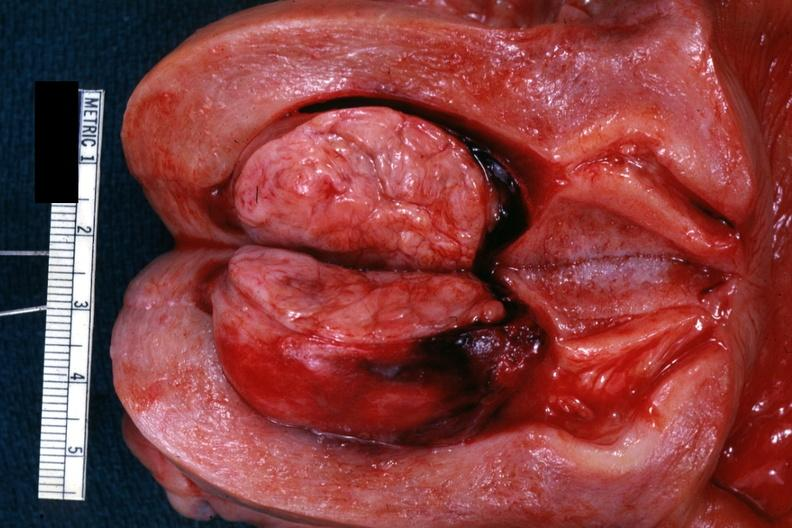s abdomen present?
Answer the question using a single word or phrase. No 